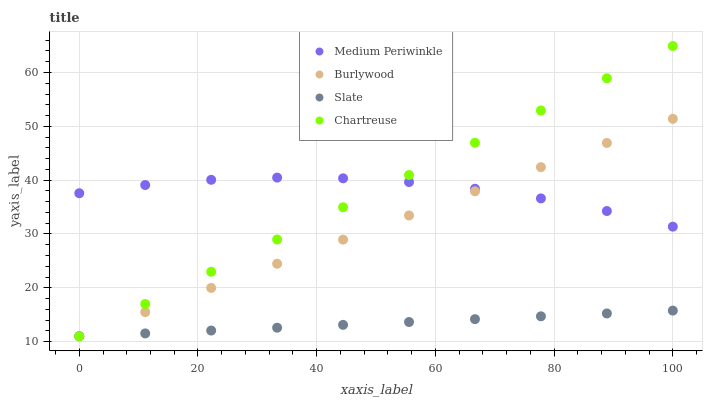Does Slate have the minimum area under the curve?
Answer yes or no. Yes. Does Medium Periwinkle have the maximum area under the curve?
Answer yes or no. Yes. Does Medium Periwinkle have the minimum area under the curve?
Answer yes or no. No. Does Slate have the maximum area under the curve?
Answer yes or no. No. Is Slate the smoothest?
Answer yes or no. Yes. Is Medium Periwinkle the roughest?
Answer yes or no. Yes. Is Medium Periwinkle the smoothest?
Answer yes or no. No. Is Slate the roughest?
Answer yes or no. No. Does Burlywood have the lowest value?
Answer yes or no. Yes. Does Medium Periwinkle have the lowest value?
Answer yes or no. No. Does Chartreuse have the highest value?
Answer yes or no. Yes. Does Medium Periwinkle have the highest value?
Answer yes or no. No. Is Slate less than Medium Periwinkle?
Answer yes or no. Yes. Is Medium Periwinkle greater than Slate?
Answer yes or no. Yes. Does Slate intersect Burlywood?
Answer yes or no. Yes. Is Slate less than Burlywood?
Answer yes or no. No. Is Slate greater than Burlywood?
Answer yes or no. No. Does Slate intersect Medium Periwinkle?
Answer yes or no. No. 